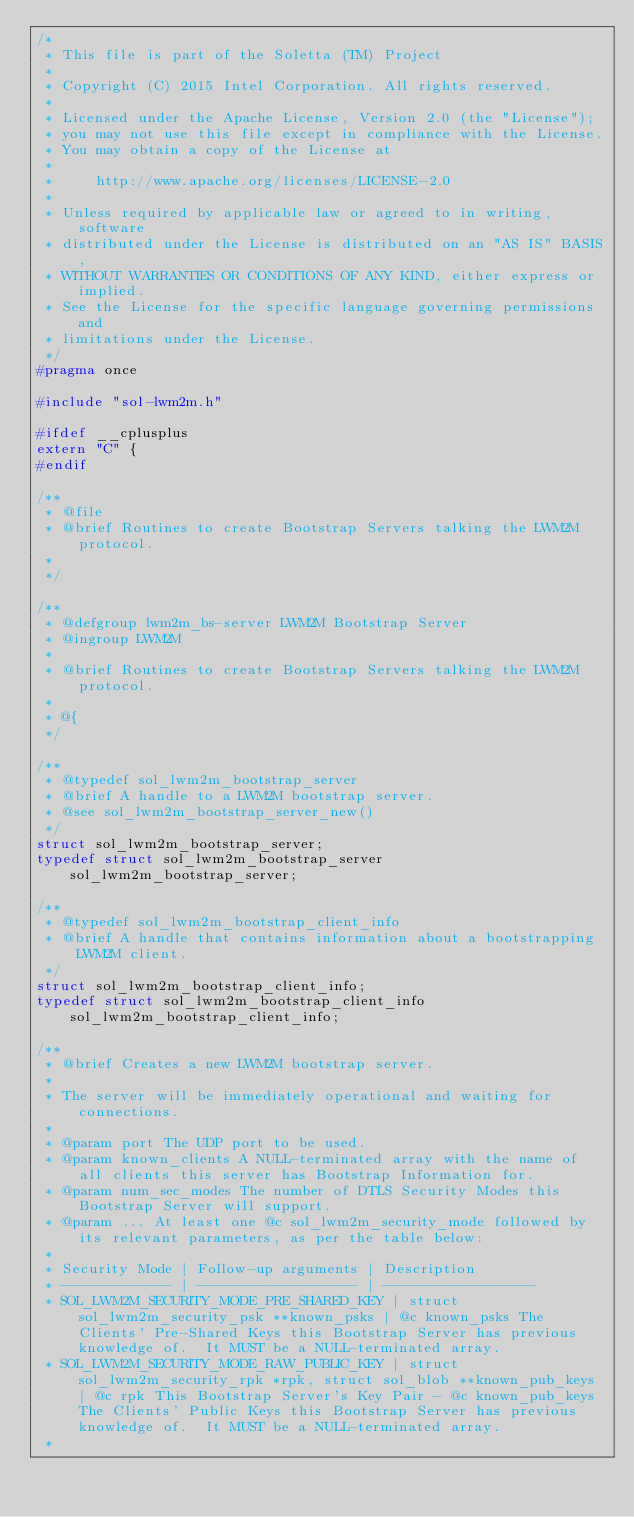<code> <loc_0><loc_0><loc_500><loc_500><_C_>/*
 * This file is part of the Soletta (TM) Project
 *
 * Copyright (C) 2015 Intel Corporation. All rights reserved.
 *
 * Licensed under the Apache License, Version 2.0 (the "License");
 * you may not use this file except in compliance with the License.
 * You may obtain a copy of the License at
 *
 *     http://www.apache.org/licenses/LICENSE-2.0
 *
 * Unless required by applicable law or agreed to in writing, software
 * distributed under the License is distributed on an "AS IS" BASIS,
 * WITHOUT WARRANTIES OR CONDITIONS OF ANY KIND, either express or implied.
 * See the License for the specific language governing permissions and
 * limitations under the License.
 */
#pragma once

#include "sol-lwm2m.h"

#ifdef __cplusplus
extern "C" {
#endif

/**
 * @file
 * @brief Routines to create Bootstrap Servers talking the LWM2M protocol.
 *
 */

/**
 * @defgroup lwm2m_bs-server LWM2M Bootstrap Server
 * @ingroup LWM2M
 *
 * @brief Routines to create Bootstrap Servers talking the LWM2M protocol.
 *
 * @{
 */

/**
 * @typedef sol_lwm2m_bootstrap_server
 * @brief A handle to a LWM2M bootstrap server.
 * @see sol_lwm2m_bootstrap_server_new()
 */
struct sol_lwm2m_bootstrap_server;
typedef struct sol_lwm2m_bootstrap_server sol_lwm2m_bootstrap_server;

/**
 * @typedef sol_lwm2m_bootstrap_client_info
 * @brief A handle that contains information about a bootstrapping LWM2M client.
 */
struct sol_lwm2m_bootstrap_client_info;
typedef struct sol_lwm2m_bootstrap_client_info sol_lwm2m_bootstrap_client_info;

/**
 * @brief Creates a new LWM2M bootstrap server.
 *
 * The server will be immediately operational and waiting for connections.
 *
 * @param port The UDP port to be used.
 * @param known_clients A NULL-terminated array with the name of all clients this server has Bootstrap Information for.
 * @param num_sec_modes The number of DTLS Security Modes this Bootstrap Server will support.
 * @param ... At least one @c sol_lwm2m_security_mode followed by its relevant parameters, as per the table below:
 *
 * Security Mode | Follow-up arguments | Description
 * ------------- | ------------------- | ------------------
 * SOL_LWM2M_SECURITY_MODE_PRE_SHARED_KEY | struct sol_lwm2m_security_psk **known_psks | @c known_psks The Clients' Pre-Shared Keys this Bootstrap Server has previous knowledge of.  It MUST be a NULL-terminated array.
 * SOL_LWM2M_SECURITY_MODE_RAW_PUBLIC_KEY | struct sol_lwm2m_security_rpk *rpk, struct sol_blob **known_pub_keys | @c rpk This Bootstrap Server's Key Pair - @c known_pub_keys The Clients' Public Keys this Bootstrap Server has previous knowledge of.  It MUST be a NULL-terminated array.
 *</code> 